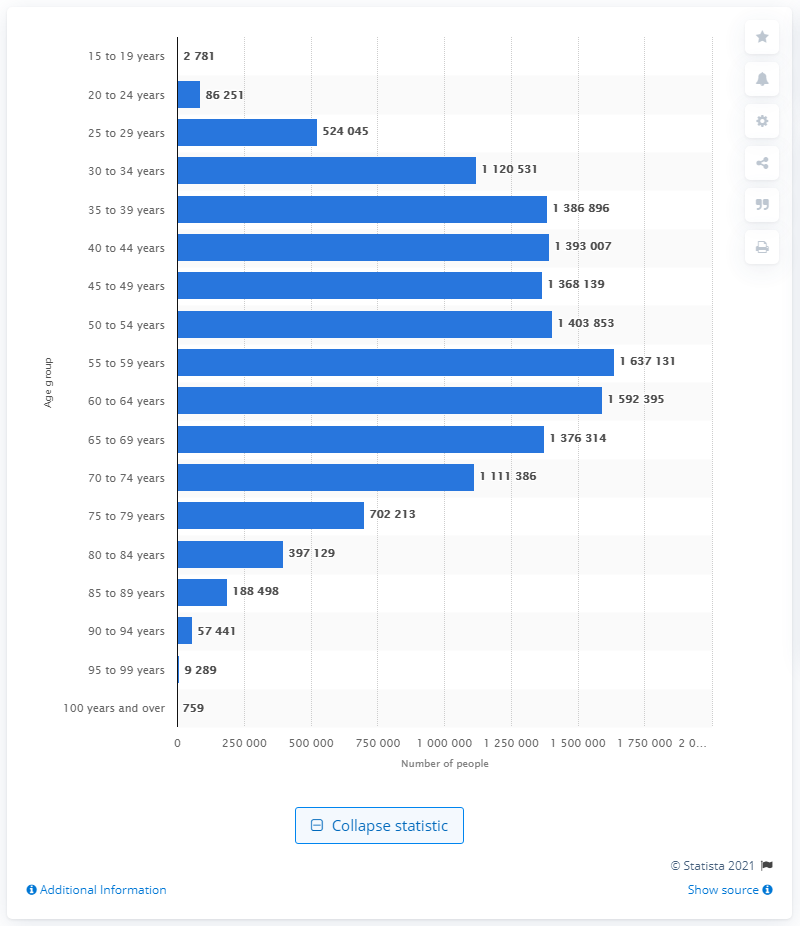Highlight a few significant elements in this photo. In 2020, there were approximately 16,371,311 married people living in Canada. 